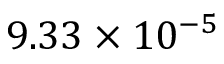Convert formula to latex. <formula><loc_0><loc_0><loc_500><loc_500>9 . 3 3 \times 1 0 ^ { - 5 }</formula> 